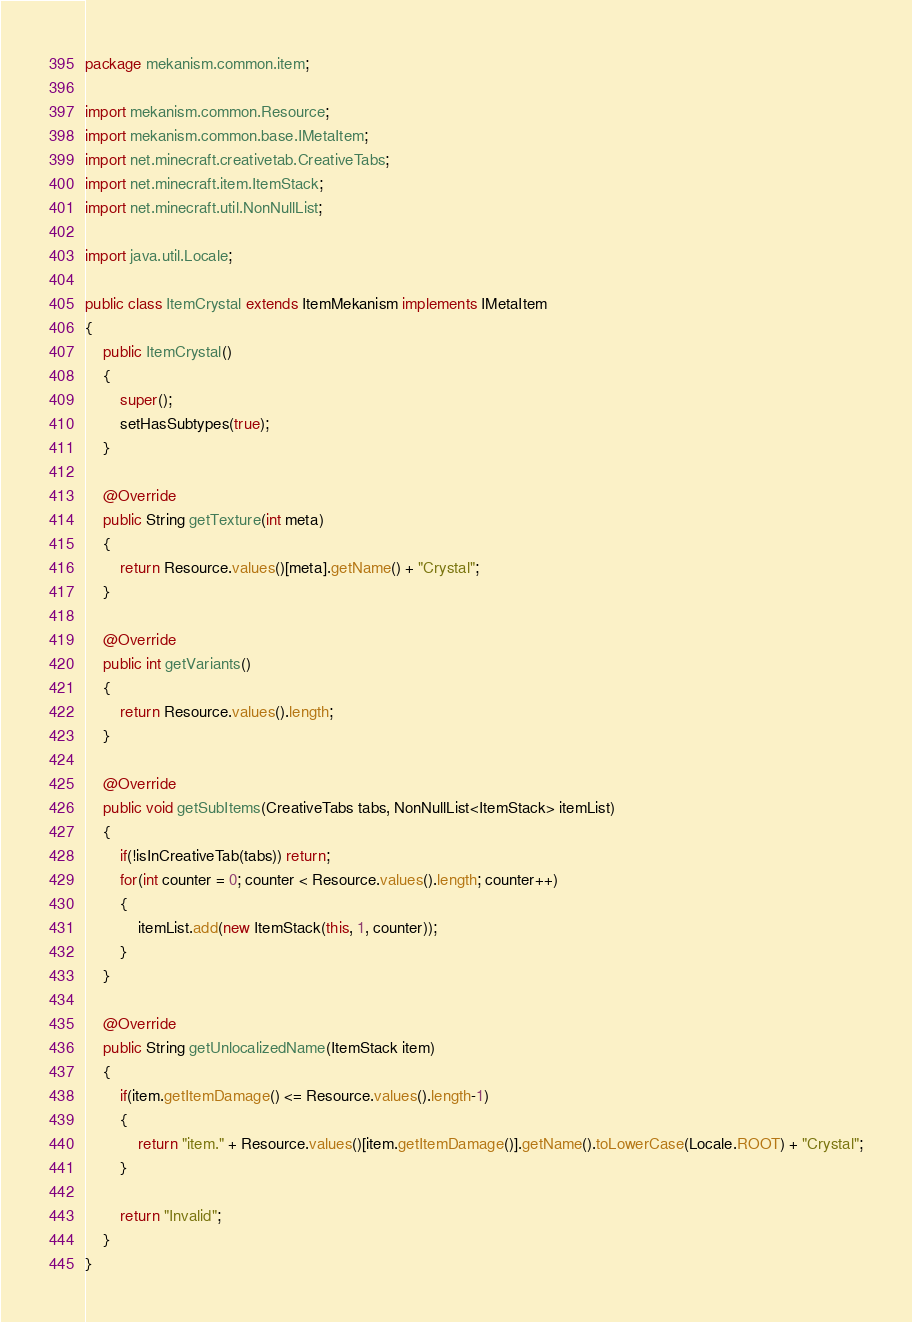Convert code to text. <code><loc_0><loc_0><loc_500><loc_500><_Java_>package mekanism.common.item;

import mekanism.common.Resource;
import mekanism.common.base.IMetaItem;
import net.minecraft.creativetab.CreativeTabs;
import net.minecraft.item.ItemStack;
import net.minecraft.util.NonNullList;

import java.util.Locale;

public class ItemCrystal extends ItemMekanism implements IMetaItem
{
	public ItemCrystal()
	{
		super();
		setHasSubtypes(true);
	}
	
	@Override
	public String getTexture(int meta)
	{
		return Resource.values()[meta].getName() + "Crystal";
	}
	
	@Override
	public int getVariants()
	{
		return Resource.values().length;
	}

	@Override
	public void getSubItems(CreativeTabs tabs, NonNullList<ItemStack> itemList)
	{
		if(!isInCreativeTab(tabs)) return;
		for(int counter = 0; counter < Resource.values().length; counter++)
		{
			itemList.add(new ItemStack(this, 1, counter));
		}
	}

	@Override
	public String getUnlocalizedName(ItemStack item)
	{
		if(item.getItemDamage() <= Resource.values().length-1)
		{
			return "item." + Resource.values()[item.getItemDamage()].getName().toLowerCase(Locale.ROOT) + "Crystal";
		}
		
		return "Invalid";
	}
}
</code> 